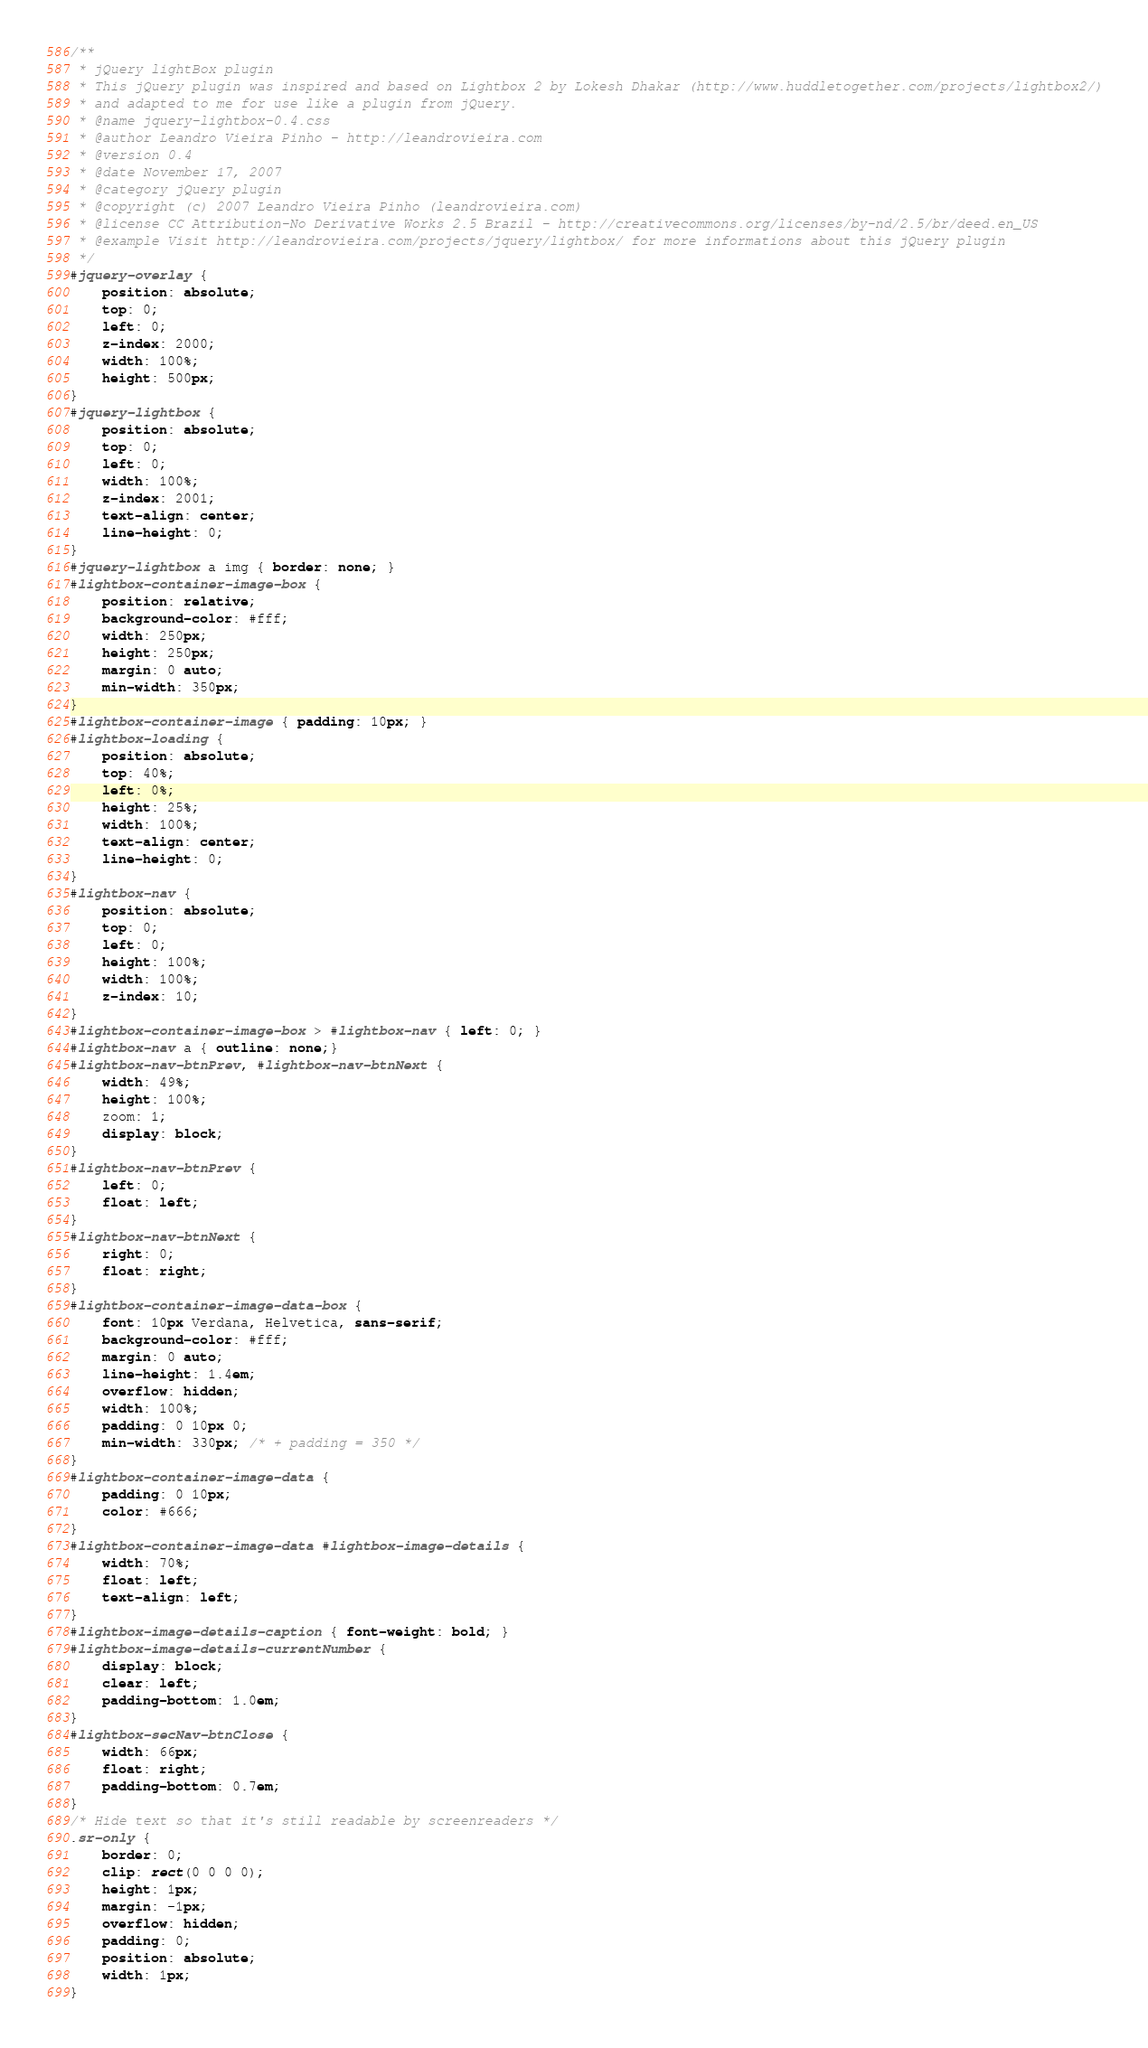<code> <loc_0><loc_0><loc_500><loc_500><_CSS_>/**
 * jQuery lightBox plugin
 * This jQuery plugin was inspired and based on Lightbox 2 by Lokesh Dhakar (http://www.huddletogether.com/projects/lightbox2/)
 * and adapted to me for use like a plugin from jQuery.
 * @name jquery-lightbox-0.4.css
 * @author Leandro Vieira Pinho - http://leandrovieira.com
 * @version 0.4
 * @date November 17, 2007
 * @category jQuery plugin
 * @copyright (c) 2007 Leandro Vieira Pinho (leandrovieira.com)
 * @license CC Attribution-No Derivative Works 2.5 Brazil - http://creativecommons.org/licenses/by-nd/2.5/br/deed.en_US
 * @example Visit http://leandrovieira.com/projects/jquery/lightbox/ for more informations about this jQuery plugin
 */
#jquery-overlay {
    position: absolute;
    top: 0;
    left: 0;
    z-index: 2000;
    width: 100%;
    height: 500px;
}
#jquery-lightbox {
    position: absolute;
    top: 0;
    left: 0;
    width: 100%;
    z-index: 2001;
    text-align: center;
    line-height: 0;
}
#jquery-lightbox a img { border: none; }
#lightbox-container-image-box {
    position: relative;
    background-color: #fff;
    width: 250px;
    height: 250px;
    margin: 0 auto;
    min-width: 350px;
}
#lightbox-container-image { padding: 10px; }
#lightbox-loading {
    position: absolute;
    top: 40%;
    left: 0%;
    height: 25%;
    width: 100%;
    text-align: center;
    line-height: 0;
}
#lightbox-nav {
    position: absolute;
    top: 0;
    left: 0;
    height: 100%;
    width: 100%;
    z-index: 10;
}
#lightbox-container-image-box > #lightbox-nav { left: 0; }
#lightbox-nav a { outline: none;}
#lightbox-nav-btnPrev, #lightbox-nav-btnNext {
    width: 49%;
    height: 100%;
    zoom: 1;
    display: block;
}
#lightbox-nav-btnPrev {
    left: 0;
    float: left;
}
#lightbox-nav-btnNext {
    right: 0;
    float: right;
}
#lightbox-container-image-data-box {
    font: 10px Verdana, Helvetica, sans-serif;
    background-color: #fff;
    margin: 0 auto;
    line-height: 1.4em;
    overflow: hidden;
    width: 100%;
    padding: 0 10px 0;
    min-width: 330px; /* + padding = 350 */
}
#lightbox-container-image-data {
    padding: 0 10px;
    color: #666;
}
#lightbox-container-image-data #lightbox-image-details {
    width: 70%;
    float: left;
    text-align: left;
}
#lightbox-image-details-caption { font-weight: bold; }
#lightbox-image-details-currentNumber {
    display: block;
    clear: left;
    padding-bottom: 1.0em;
}
#lightbox-secNav-btnClose {
    width: 66px;
    float: right;
    padding-bottom: 0.7em;
}
/* Hide text so that it's still readable by screenreaders */
.sr-only {
    border: 0;
    clip: rect(0 0 0 0);
    height: 1px;
    margin: -1px;
    overflow: hidden;
    padding: 0;
    position: absolute;
    width: 1px;
}
</code> 